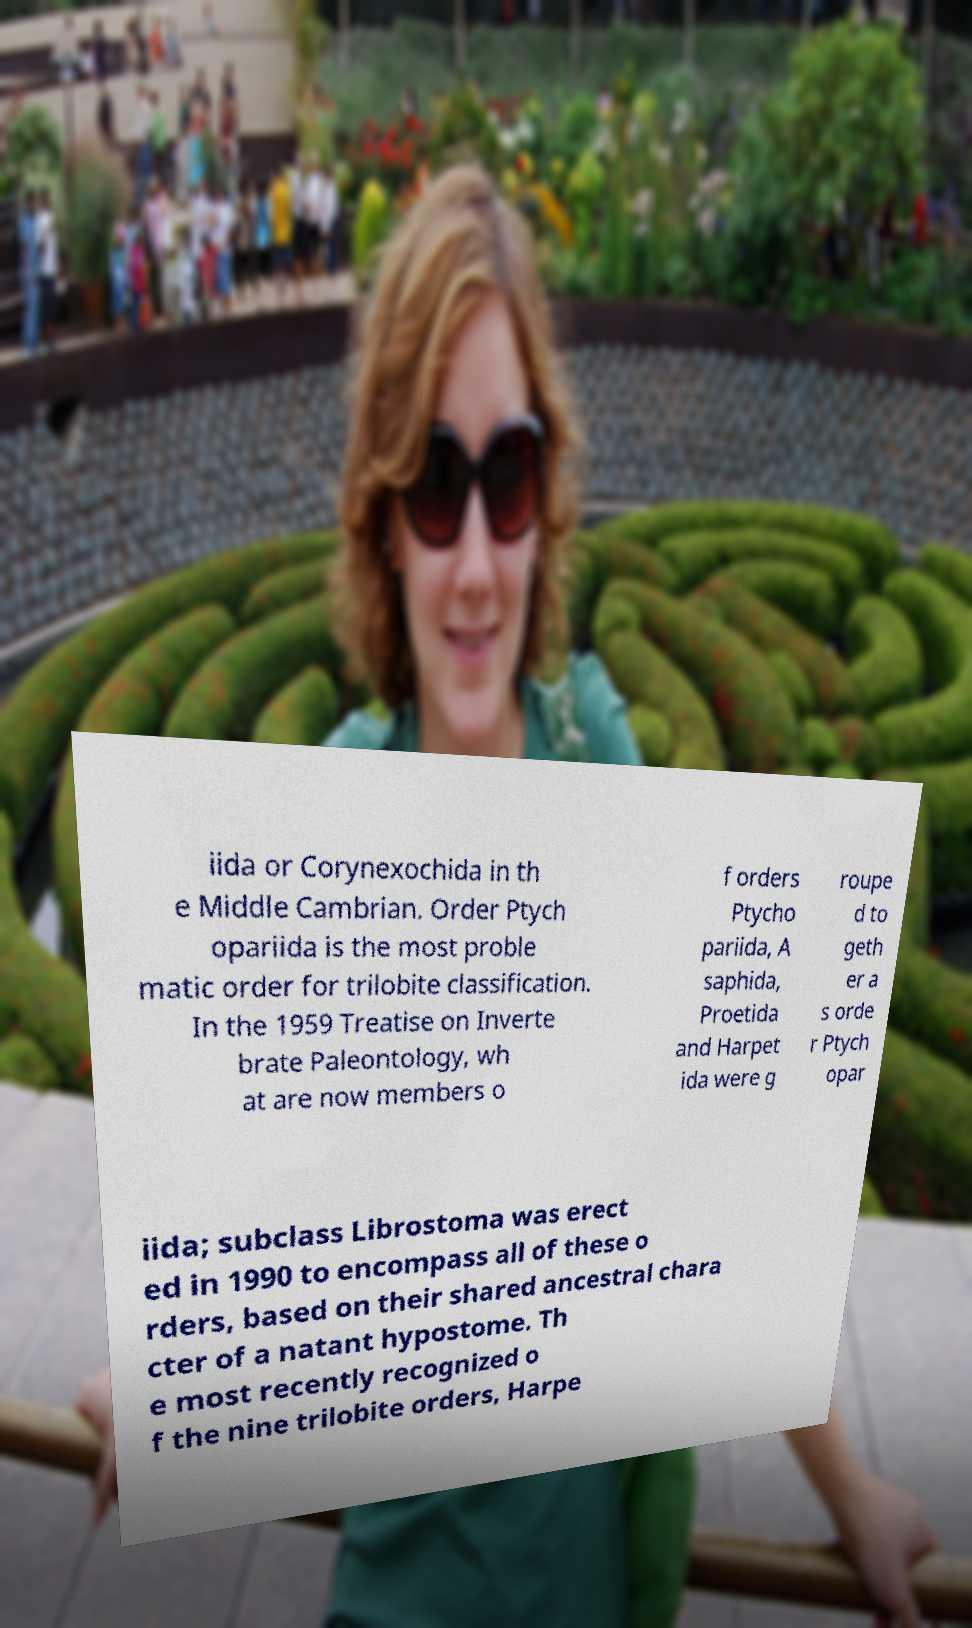Please read and relay the text visible in this image. What does it say? iida or Corynexochida in th e Middle Cambrian. Order Ptych opariida is the most proble matic order for trilobite classification. In the 1959 Treatise on Inverte brate Paleontology, wh at are now members o f orders Ptycho pariida, A saphida, Proetida and Harpet ida were g roupe d to geth er a s orde r Ptych opar iida; subclass Librostoma was erect ed in 1990 to encompass all of these o rders, based on their shared ancestral chara cter of a natant hypostome. Th e most recently recognized o f the nine trilobite orders, Harpe 